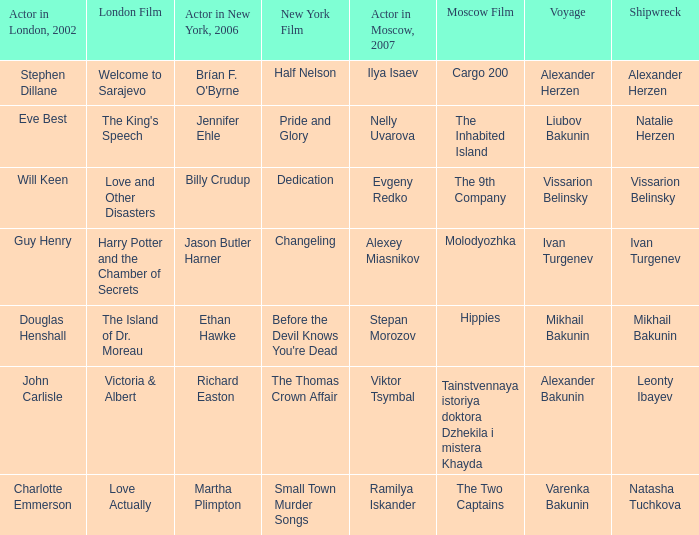Who was the 2007 actor from Moscow for the voyage of Varenka Bakunin? Ramilya Iskander. 